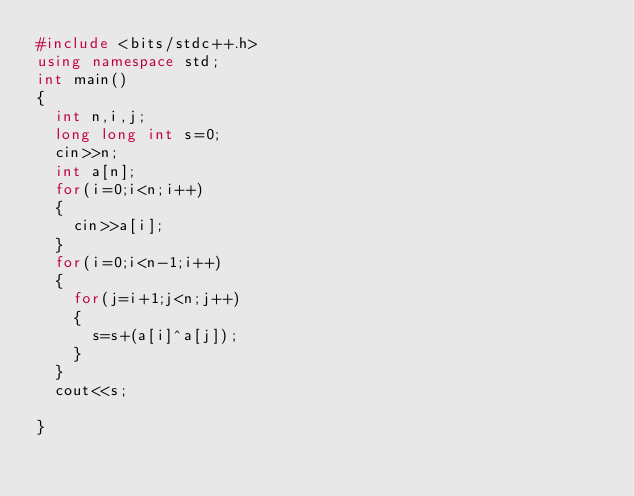Convert code to text. <code><loc_0><loc_0><loc_500><loc_500><_C++_>#include <bits/stdc++.h>
using namespace std;
int main()
{
  int n,i,j;
  long long int s=0;
  cin>>n;
  int a[n];
  for(i=0;i<n;i++)
  {
    cin>>a[i];
  }
  for(i=0;i<n-1;i++)
  {
    for(j=i+1;j<n;j++)
    {
      s=s+(a[i]^a[j]);
    }
  }
  cout<<s;
  
}
 </code> 